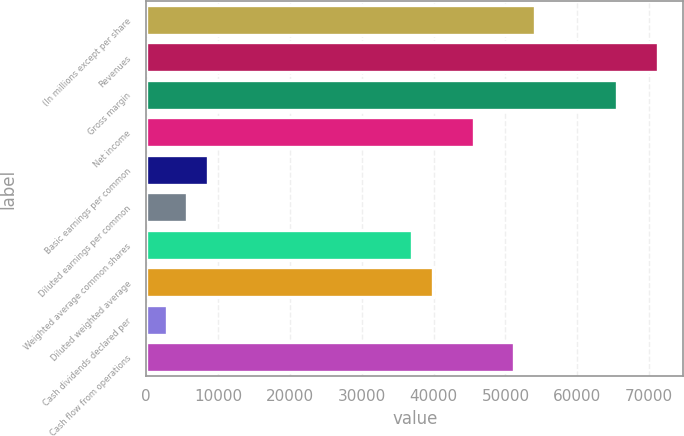Convert chart to OTSL. <chart><loc_0><loc_0><loc_500><loc_500><bar_chart><fcel>(In millions except per share<fcel>Revenues<fcel>Gross margin<fcel>Net income<fcel>Basic earnings per common<fcel>Diluted earnings per common<fcel>Weighted average common shares<fcel>Diluted weighted average<fcel>Cash dividends declared per<fcel>Cash flow from operations<nl><fcel>54096.5<fcel>71179.6<fcel>65485.2<fcel>45555<fcel>8541.81<fcel>5694.64<fcel>37013.5<fcel>39860.7<fcel>2847.47<fcel>51249.4<nl></chart> 